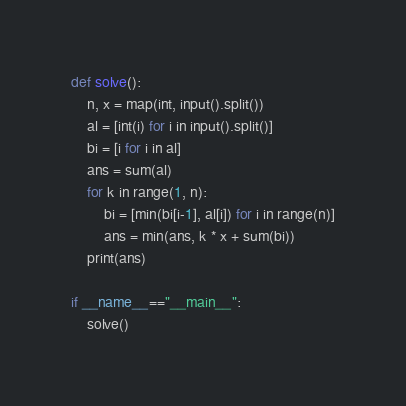Convert code to text. <code><loc_0><loc_0><loc_500><loc_500><_Python_>def solve():
    n, x = map(int, input().split())
    al = [int(i) for i in input().split()]
    bi = [i for i in al]
    ans = sum(al)
    for k in range(1, n):
        bi = [min(bi[i-1], al[i]) for i in range(n)]
        ans = min(ans, k * x + sum(bi))
    print(ans)

if __name__=="__main__":
    solve()</code> 